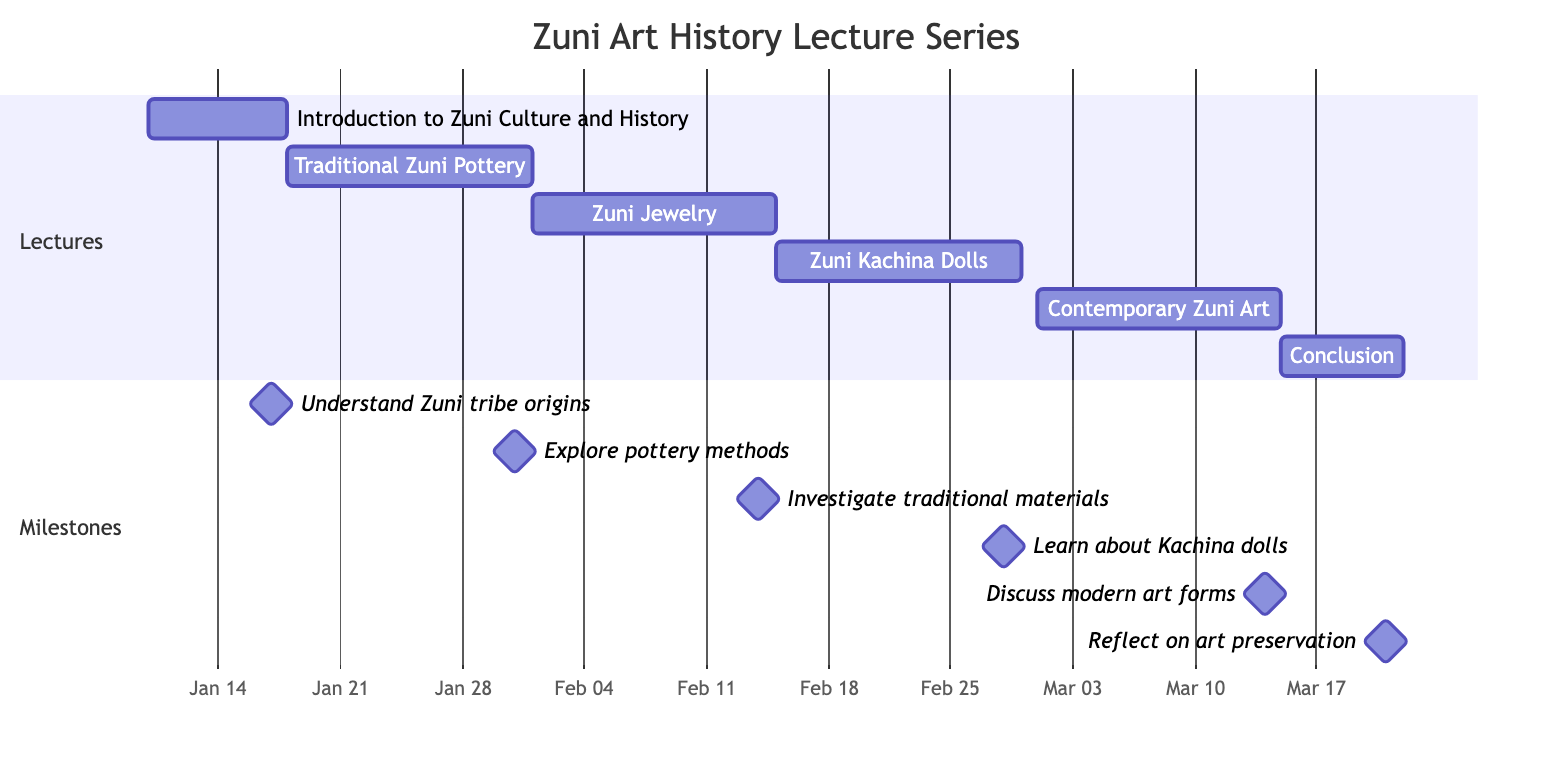What is the duration of the first lecture? The first lecture, "Introduction to Zuni Culture and History," starts on January 10, 2024, and ends on January 17, 2024. Therefore, its duration is from start to end, which is 8 days.
Answer: 8 days How many total lectures are planned? Counting the list of lectures shown in the Gantt chart, there are a total of 6 lectures scheduled in the series.
Answer: 6 What is the milestone for the lecture on Zuni Jewelry? The milestone for the lecture titled "Zuni Jewelry: Materials and Symbolism," scheduled from February 1 to February 14, 2024, is to "Investigate the use of traditional materials and their meanings."
Answer: Investigate the use of traditional materials and their meanings Which lecture comes right before the concluding lecture? The concluding lecture titled "Conclusion: The Future of Zuni Art" is the last one, scheduled from March 15 to March 21, 2024. The lecture right before it is "Contemporary Zuni Art: Evolution and Trends," scheduled from March 1 to March 14, 2024.
Answer: Contemporary Zuni Art: Evolution and Trends When does the lecture on Zuni Kachina Dolls start? The lecture on "Zuni Kachina Dolls: Cultural Significance" starts on February 15, 2024, as indicated by its scheduling on the Gantt chart.
Answer: February 15, 2024 What is the total duration of the Zuni art lecture series? The series includes the first lecture starting on January 10 and the last lecture ending on March 21, 2024. The total duration from the first to the last lecture is 70 days.
Answer: 70 days What is the primary focus of the lecture on Contemporary Zuni Art? For the lecture titled "Contemporary Zuni Art: Evolution and Trends," the focus is to "Discuss the transition from traditional to modern art forms," as indicated in the milestone.
Answer: Discuss the transition from traditional to modern art forms In which month does the lecture about Traditional Zuni Pottery begin? The lecture "Traditional Zuni Pottery: Techniques and Styles" begins on January 18, 2024. Since January is the first month of the year, the lecture starts in January.
Answer: January 